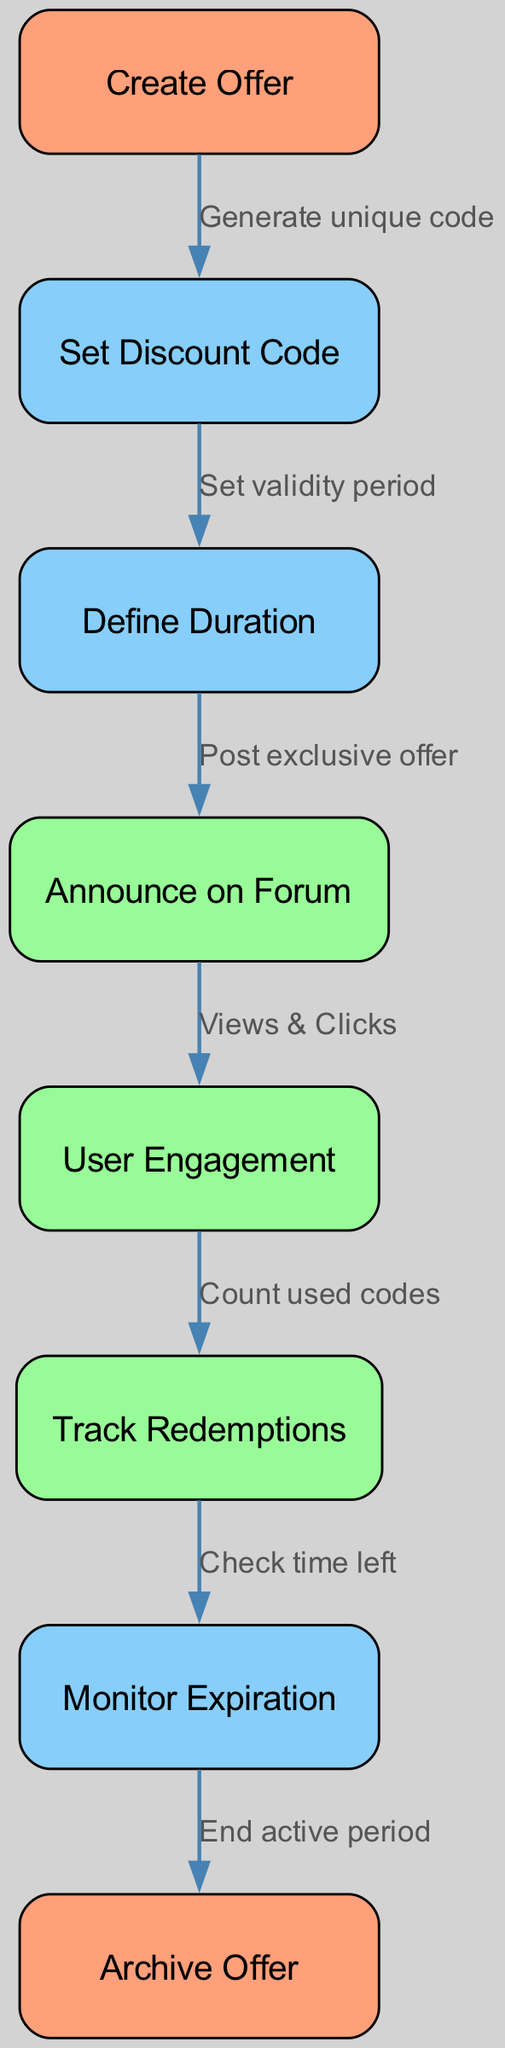What is the first step in the lifecycle of a limited-time offer? The first step is labeled "Create Offer," which initiates the entire process flow for setting up a limited-time offer.
Answer: Create Offer How many nodes are displayed in the diagram? The diagram includes a total of eight nodes, representing various stages in the lifecycle of the offer from creation to expiration.
Answer: Eight What is the label for the node preceding "Announce on Forum"? The node preceding "Announce on Forum" is "Define Duration," which signifies that the validity period must be established before announcing the offer.
Answer: Define Duration Which step involves tracking user engagement? The step that involves tracking user engagement is labeled "User Engagement," indicating that this is when the system monitors interactions with the offer.
Answer: User Engagement What action occurs after "Track Redemptions"? After "Track Redemptions," the next action is "Monitor Expiration," which ensures that the offer's validity period is continuously checked.
Answer: Monitor Expiration What is the relationship between "Set Discount Code" and "Define Duration"? The relationship is that "Set Discount Code" leads to "Define Duration" with the specified action being "Set validity period," indicating that discount codes require a defined timeframe for validity.
Answer: Set validity period What color represents the key action nodes in the diagram? The key action nodes in the diagram are represented in light green, specifically the nodes for "Announce on Forum," "User Engagement," and "Track Redemptions."
Answer: Light green Which step concludes the lifecycle of the offer? The lifecycle of the offer concludes with the step labeled "Archive Offer," indicating the end of the process after monitoring its expiration.
Answer: Archive Offer 